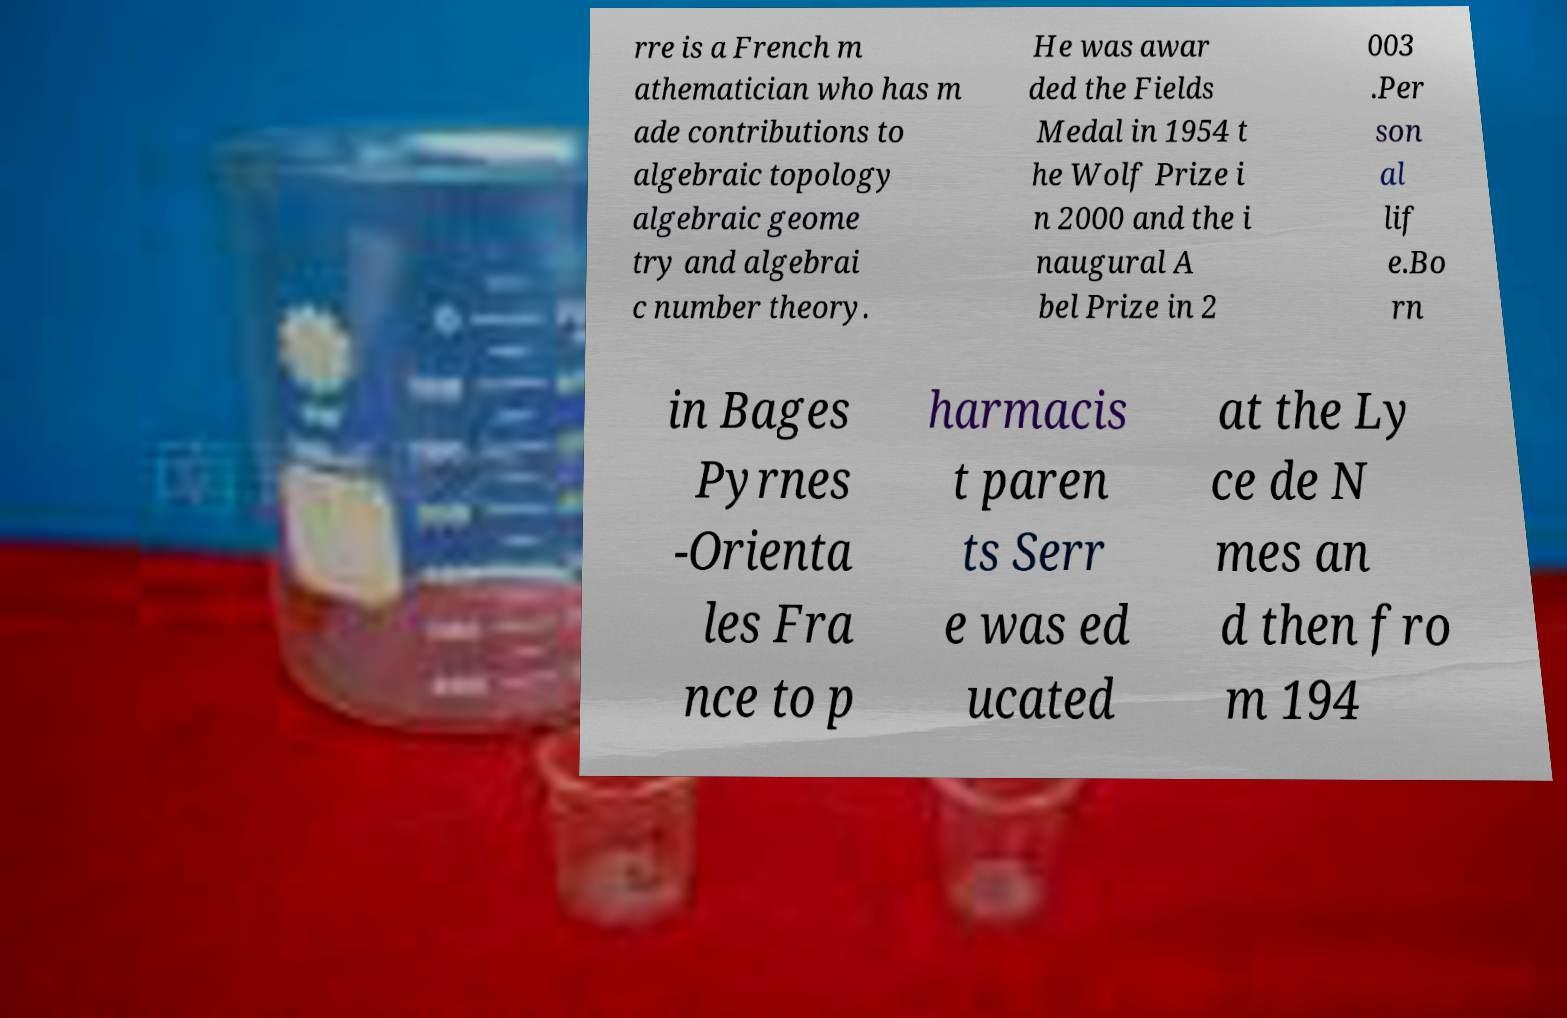Can you accurately transcribe the text from the provided image for me? rre is a French m athematician who has m ade contributions to algebraic topology algebraic geome try and algebrai c number theory. He was awar ded the Fields Medal in 1954 t he Wolf Prize i n 2000 and the i naugural A bel Prize in 2 003 .Per son al lif e.Bo rn in Bages Pyrnes -Orienta les Fra nce to p harmacis t paren ts Serr e was ed ucated at the Ly ce de N mes an d then fro m 194 